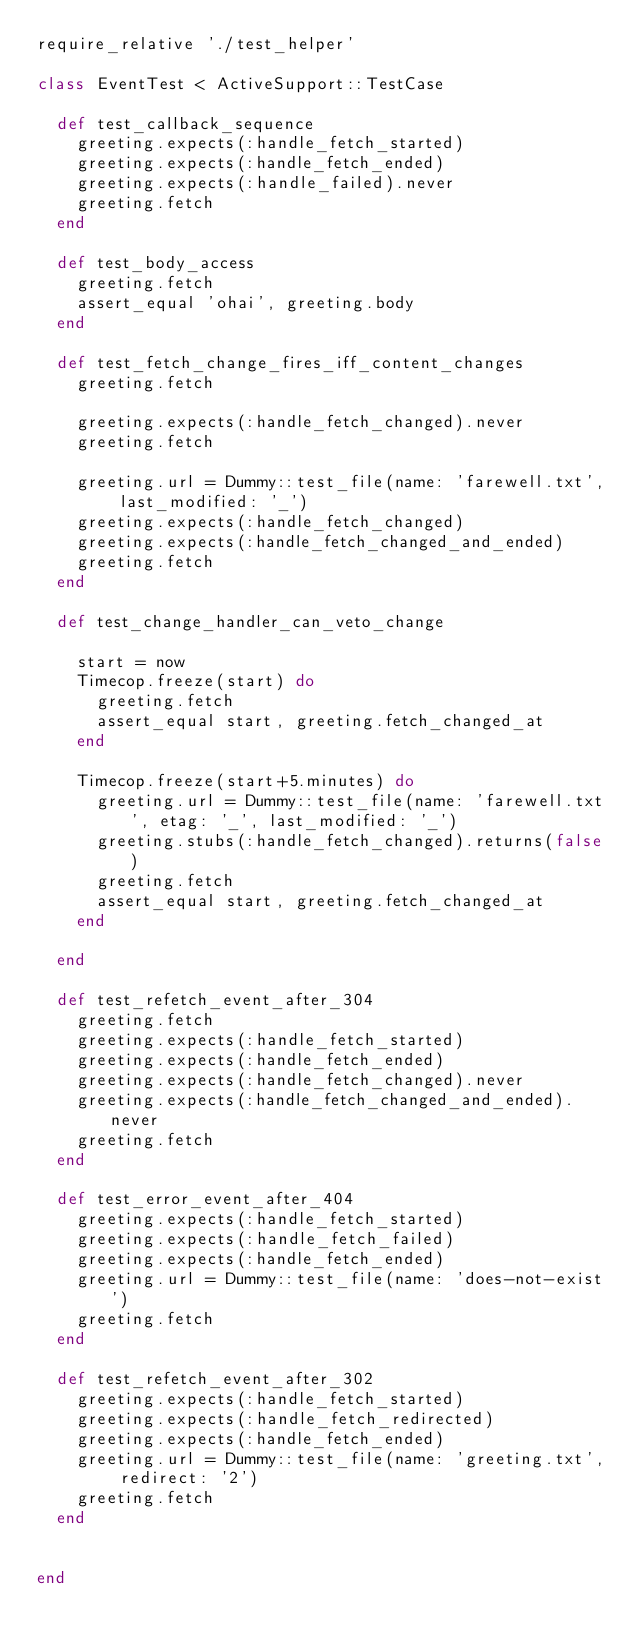Convert code to text. <code><loc_0><loc_0><loc_500><loc_500><_Ruby_>require_relative './test_helper'

class EventTest < ActiveSupport::TestCase

  def test_callback_sequence
    greeting.expects(:handle_fetch_started)
    greeting.expects(:handle_fetch_ended)
    greeting.expects(:handle_failed).never
    greeting.fetch
  end

  def test_body_access
    greeting.fetch
    assert_equal 'ohai', greeting.body
  end

  def test_fetch_change_fires_iff_content_changes
    greeting.fetch

    greeting.expects(:handle_fetch_changed).never
    greeting.fetch

    greeting.url = Dummy::test_file(name: 'farewell.txt', last_modified: '_')
    greeting.expects(:handle_fetch_changed)
    greeting.expects(:handle_fetch_changed_and_ended)
    greeting.fetch
  end

  def test_change_handler_can_veto_change

    start = now
    Timecop.freeze(start) do
      greeting.fetch
      assert_equal start, greeting.fetch_changed_at
    end
    
    Timecop.freeze(start+5.minutes) do
      greeting.url = Dummy::test_file(name: 'farewell.txt', etag: '_', last_modified: '_')
      greeting.stubs(:handle_fetch_changed).returns(false)
      greeting.fetch
      assert_equal start, greeting.fetch_changed_at
    end

  end

  def test_refetch_event_after_304
    greeting.fetch
    greeting.expects(:handle_fetch_started)
    greeting.expects(:handle_fetch_ended)
    greeting.expects(:handle_fetch_changed).never
    greeting.expects(:handle_fetch_changed_and_ended).never
    greeting.fetch
  end

  def test_error_event_after_404
    greeting.expects(:handle_fetch_started)
    greeting.expects(:handle_fetch_failed)
    greeting.expects(:handle_fetch_ended)
    greeting.url = Dummy::test_file(name: 'does-not-exist')
    greeting.fetch
  end

  def test_refetch_event_after_302
    greeting.expects(:handle_fetch_started)
    greeting.expects(:handle_fetch_redirected)
    greeting.expects(:handle_fetch_ended)
    greeting.url = Dummy::test_file(name: 'greeting.txt', redirect: '2')
    greeting.fetch
  end


end
</code> 